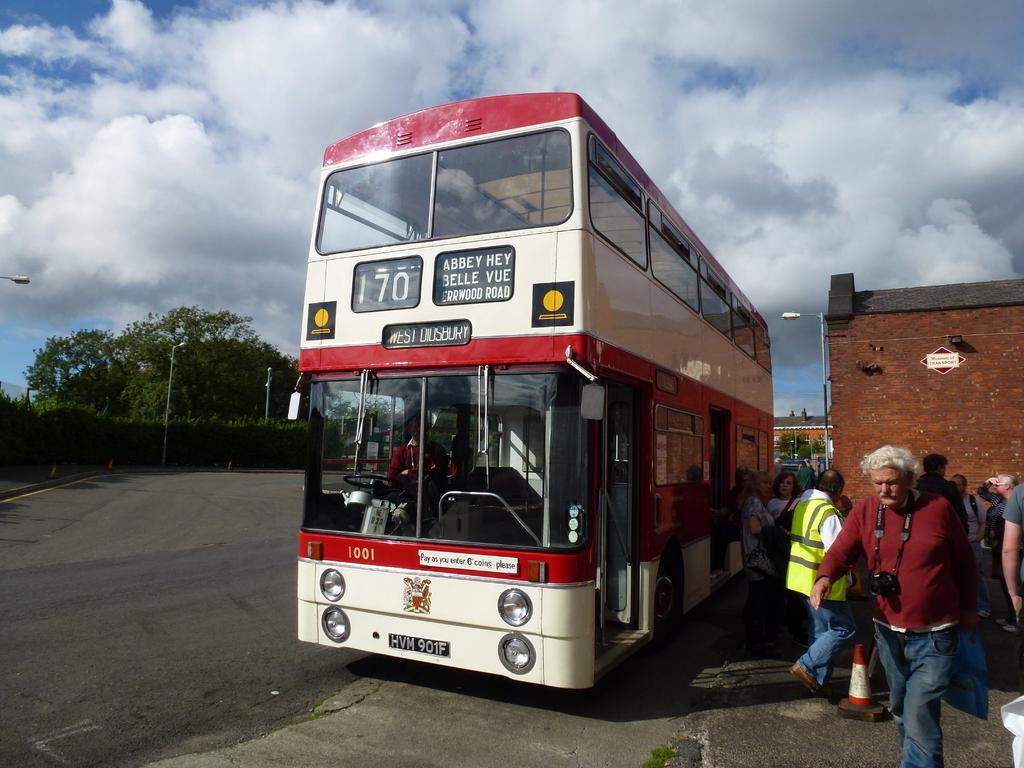<image>
Describe the image concisely. a double decker bus number 170 headed to West Didsbury 